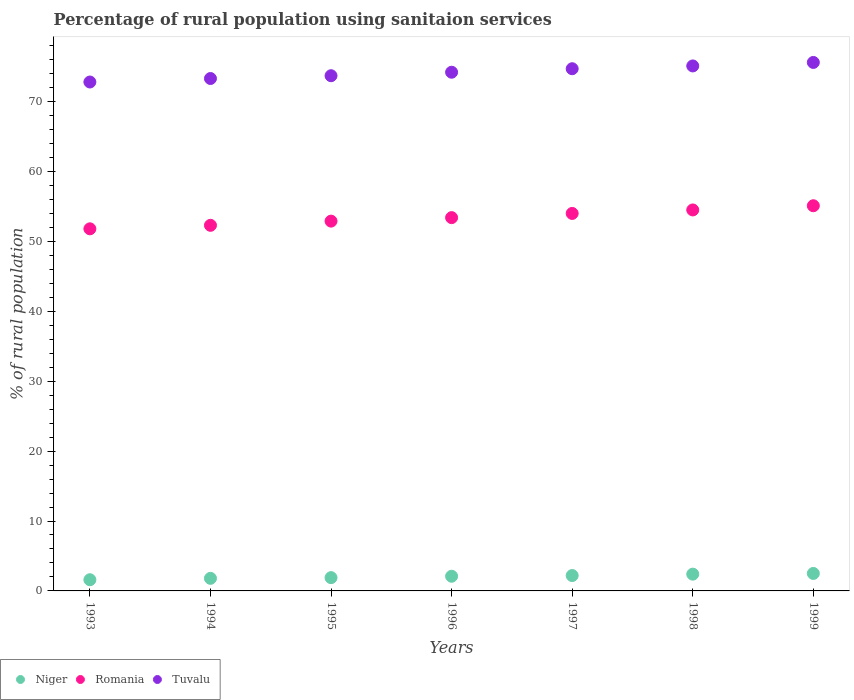What is the percentage of rural population using sanitaion services in Tuvalu in 1994?
Your response must be concise. 73.3. Across all years, what is the maximum percentage of rural population using sanitaion services in Tuvalu?
Make the answer very short. 75.6. Across all years, what is the minimum percentage of rural population using sanitaion services in Tuvalu?
Your answer should be compact. 72.8. In which year was the percentage of rural population using sanitaion services in Tuvalu maximum?
Your answer should be very brief. 1999. In which year was the percentage of rural population using sanitaion services in Niger minimum?
Ensure brevity in your answer.  1993. What is the total percentage of rural population using sanitaion services in Romania in the graph?
Make the answer very short. 374. What is the difference between the percentage of rural population using sanitaion services in Niger in 1993 and that in 1998?
Your answer should be compact. -0.8. What is the difference between the percentage of rural population using sanitaion services in Tuvalu in 1998 and the percentage of rural population using sanitaion services in Romania in 1997?
Your answer should be compact. 21.1. What is the average percentage of rural population using sanitaion services in Tuvalu per year?
Give a very brief answer. 74.2. In the year 1996, what is the difference between the percentage of rural population using sanitaion services in Romania and percentage of rural population using sanitaion services in Niger?
Your answer should be very brief. 51.3. What is the ratio of the percentage of rural population using sanitaion services in Niger in 1995 to that in 1997?
Provide a succinct answer. 0.86. Is the percentage of rural population using sanitaion services in Romania in 1993 less than that in 1998?
Provide a short and direct response. Yes. What is the difference between the highest and the lowest percentage of rural population using sanitaion services in Romania?
Provide a short and direct response. 3.3. In how many years, is the percentage of rural population using sanitaion services in Niger greater than the average percentage of rural population using sanitaion services in Niger taken over all years?
Provide a succinct answer. 4. Is the sum of the percentage of rural population using sanitaion services in Niger in 1995 and 1999 greater than the maximum percentage of rural population using sanitaion services in Romania across all years?
Your response must be concise. No. Is it the case that in every year, the sum of the percentage of rural population using sanitaion services in Romania and percentage of rural population using sanitaion services in Tuvalu  is greater than the percentage of rural population using sanitaion services in Niger?
Offer a terse response. Yes. Is the percentage of rural population using sanitaion services in Niger strictly less than the percentage of rural population using sanitaion services in Romania over the years?
Keep it short and to the point. Yes. How many dotlines are there?
Keep it short and to the point. 3. Are the values on the major ticks of Y-axis written in scientific E-notation?
Offer a terse response. No. Does the graph contain any zero values?
Make the answer very short. No. Does the graph contain grids?
Provide a short and direct response. No. How are the legend labels stacked?
Provide a short and direct response. Horizontal. What is the title of the graph?
Your response must be concise. Percentage of rural population using sanitaion services. What is the label or title of the X-axis?
Keep it short and to the point. Years. What is the label or title of the Y-axis?
Your response must be concise. % of rural population. What is the % of rural population in Niger in 1993?
Ensure brevity in your answer.  1.6. What is the % of rural population in Romania in 1993?
Give a very brief answer. 51.8. What is the % of rural population of Tuvalu in 1993?
Offer a terse response. 72.8. What is the % of rural population in Niger in 1994?
Provide a short and direct response. 1.8. What is the % of rural population in Romania in 1994?
Make the answer very short. 52.3. What is the % of rural population in Tuvalu in 1994?
Ensure brevity in your answer.  73.3. What is the % of rural population of Niger in 1995?
Your answer should be very brief. 1.9. What is the % of rural population in Romania in 1995?
Give a very brief answer. 52.9. What is the % of rural population in Tuvalu in 1995?
Ensure brevity in your answer.  73.7. What is the % of rural population of Romania in 1996?
Offer a terse response. 53.4. What is the % of rural population in Tuvalu in 1996?
Offer a terse response. 74.2. What is the % of rural population in Niger in 1997?
Provide a succinct answer. 2.2. What is the % of rural population in Romania in 1997?
Your answer should be compact. 54. What is the % of rural population of Tuvalu in 1997?
Ensure brevity in your answer.  74.7. What is the % of rural population of Romania in 1998?
Your answer should be compact. 54.5. What is the % of rural population of Tuvalu in 1998?
Your response must be concise. 75.1. What is the % of rural population of Niger in 1999?
Make the answer very short. 2.5. What is the % of rural population in Romania in 1999?
Provide a succinct answer. 55.1. What is the % of rural population of Tuvalu in 1999?
Make the answer very short. 75.6. Across all years, what is the maximum % of rural population of Niger?
Give a very brief answer. 2.5. Across all years, what is the maximum % of rural population in Romania?
Your response must be concise. 55.1. Across all years, what is the maximum % of rural population in Tuvalu?
Keep it short and to the point. 75.6. Across all years, what is the minimum % of rural population of Romania?
Your answer should be very brief. 51.8. Across all years, what is the minimum % of rural population of Tuvalu?
Give a very brief answer. 72.8. What is the total % of rural population of Niger in the graph?
Offer a very short reply. 14.5. What is the total % of rural population in Romania in the graph?
Provide a succinct answer. 374. What is the total % of rural population of Tuvalu in the graph?
Your response must be concise. 519.4. What is the difference between the % of rural population in Niger in 1993 and that in 1994?
Offer a very short reply. -0.2. What is the difference between the % of rural population in Romania in 1993 and that in 1995?
Keep it short and to the point. -1.1. What is the difference between the % of rural population of Tuvalu in 1993 and that in 1996?
Make the answer very short. -1.4. What is the difference between the % of rural population of Niger in 1993 and that in 1997?
Your response must be concise. -0.6. What is the difference between the % of rural population in Niger in 1993 and that in 1998?
Ensure brevity in your answer.  -0.8. What is the difference between the % of rural population of Romania in 1993 and that in 1998?
Your response must be concise. -2.7. What is the difference between the % of rural population in Tuvalu in 1993 and that in 1998?
Keep it short and to the point. -2.3. What is the difference between the % of rural population in Romania in 1993 and that in 1999?
Ensure brevity in your answer.  -3.3. What is the difference between the % of rural population of Tuvalu in 1993 and that in 1999?
Your answer should be very brief. -2.8. What is the difference between the % of rural population in Niger in 1994 and that in 1995?
Make the answer very short. -0.1. What is the difference between the % of rural population of Tuvalu in 1994 and that in 1995?
Offer a very short reply. -0.4. What is the difference between the % of rural population in Niger in 1994 and that in 1996?
Provide a succinct answer. -0.3. What is the difference between the % of rural population of Romania in 1994 and that in 1996?
Your response must be concise. -1.1. What is the difference between the % of rural population of Tuvalu in 1994 and that in 1996?
Offer a terse response. -0.9. What is the difference between the % of rural population of Niger in 1994 and that in 1997?
Your response must be concise. -0.4. What is the difference between the % of rural population of Romania in 1994 and that in 1997?
Give a very brief answer. -1.7. What is the difference between the % of rural population of Niger in 1994 and that in 1998?
Keep it short and to the point. -0.6. What is the difference between the % of rural population in Tuvalu in 1994 and that in 1998?
Ensure brevity in your answer.  -1.8. What is the difference between the % of rural population in Niger in 1994 and that in 1999?
Keep it short and to the point. -0.7. What is the difference between the % of rural population of Tuvalu in 1994 and that in 1999?
Offer a very short reply. -2.3. What is the difference between the % of rural population of Niger in 1995 and that in 1996?
Provide a succinct answer. -0.2. What is the difference between the % of rural population in Romania in 1995 and that in 1996?
Ensure brevity in your answer.  -0.5. What is the difference between the % of rural population of Tuvalu in 1995 and that in 1996?
Offer a terse response. -0.5. What is the difference between the % of rural population in Niger in 1995 and that in 1997?
Make the answer very short. -0.3. What is the difference between the % of rural population of Romania in 1995 and that in 1997?
Your response must be concise. -1.1. What is the difference between the % of rural population of Niger in 1995 and that in 1998?
Give a very brief answer. -0.5. What is the difference between the % of rural population of Romania in 1995 and that in 1998?
Your answer should be compact. -1.6. What is the difference between the % of rural population in Tuvalu in 1995 and that in 1998?
Provide a succinct answer. -1.4. What is the difference between the % of rural population in Niger in 1995 and that in 1999?
Make the answer very short. -0.6. What is the difference between the % of rural population in Niger in 1996 and that in 1999?
Keep it short and to the point. -0.4. What is the difference between the % of rural population in Niger in 1997 and that in 1998?
Make the answer very short. -0.2. What is the difference between the % of rural population of Romania in 1997 and that in 1998?
Offer a terse response. -0.5. What is the difference between the % of rural population of Tuvalu in 1997 and that in 1998?
Keep it short and to the point. -0.4. What is the difference between the % of rural population of Niger in 1993 and the % of rural population of Romania in 1994?
Offer a terse response. -50.7. What is the difference between the % of rural population in Niger in 1993 and the % of rural population in Tuvalu in 1994?
Offer a very short reply. -71.7. What is the difference between the % of rural population in Romania in 1993 and the % of rural population in Tuvalu in 1994?
Ensure brevity in your answer.  -21.5. What is the difference between the % of rural population of Niger in 1993 and the % of rural population of Romania in 1995?
Ensure brevity in your answer.  -51.3. What is the difference between the % of rural population of Niger in 1993 and the % of rural population of Tuvalu in 1995?
Your answer should be very brief. -72.1. What is the difference between the % of rural population of Romania in 1993 and the % of rural population of Tuvalu in 1995?
Your answer should be compact. -21.9. What is the difference between the % of rural population in Niger in 1993 and the % of rural population in Romania in 1996?
Ensure brevity in your answer.  -51.8. What is the difference between the % of rural population in Niger in 1993 and the % of rural population in Tuvalu in 1996?
Keep it short and to the point. -72.6. What is the difference between the % of rural population of Romania in 1993 and the % of rural population of Tuvalu in 1996?
Offer a very short reply. -22.4. What is the difference between the % of rural population of Niger in 1993 and the % of rural population of Romania in 1997?
Your answer should be compact. -52.4. What is the difference between the % of rural population in Niger in 1993 and the % of rural population in Tuvalu in 1997?
Your answer should be very brief. -73.1. What is the difference between the % of rural population of Romania in 1993 and the % of rural population of Tuvalu in 1997?
Provide a short and direct response. -22.9. What is the difference between the % of rural population of Niger in 1993 and the % of rural population of Romania in 1998?
Provide a short and direct response. -52.9. What is the difference between the % of rural population in Niger in 1993 and the % of rural population in Tuvalu in 1998?
Make the answer very short. -73.5. What is the difference between the % of rural population of Romania in 1993 and the % of rural population of Tuvalu in 1998?
Offer a terse response. -23.3. What is the difference between the % of rural population in Niger in 1993 and the % of rural population in Romania in 1999?
Offer a terse response. -53.5. What is the difference between the % of rural population in Niger in 1993 and the % of rural population in Tuvalu in 1999?
Keep it short and to the point. -74. What is the difference between the % of rural population of Romania in 1993 and the % of rural population of Tuvalu in 1999?
Your response must be concise. -23.8. What is the difference between the % of rural population in Niger in 1994 and the % of rural population in Romania in 1995?
Provide a short and direct response. -51.1. What is the difference between the % of rural population of Niger in 1994 and the % of rural population of Tuvalu in 1995?
Provide a short and direct response. -71.9. What is the difference between the % of rural population in Romania in 1994 and the % of rural population in Tuvalu in 1995?
Provide a short and direct response. -21.4. What is the difference between the % of rural population of Niger in 1994 and the % of rural population of Romania in 1996?
Your response must be concise. -51.6. What is the difference between the % of rural population in Niger in 1994 and the % of rural population in Tuvalu in 1996?
Your response must be concise. -72.4. What is the difference between the % of rural population in Romania in 1994 and the % of rural population in Tuvalu in 1996?
Provide a succinct answer. -21.9. What is the difference between the % of rural population of Niger in 1994 and the % of rural population of Romania in 1997?
Ensure brevity in your answer.  -52.2. What is the difference between the % of rural population in Niger in 1994 and the % of rural population in Tuvalu in 1997?
Your answer should be compact. -72.9. What is the difference between the % of rural population in Romania in 1994 and the % of rural population in Tuvalu in 1997?
Your response must be concise. -22.4. What is the difference between the % of rural population in Niger in 1994 and the % of rural population in Romania in 1998?
Give a very brief answer. -52.7. What is the difference between the % of rural population of Niger in 1994 and the % of rural population of Tuvalu in 1998?
Make the answer very short. -73.3. What is the difference between the % of rural population in Romania in 1994 and the % of rural population in Tuvalu in 1998?
Make the answer very short. -22.8. What is the difference between the % of rural population of Niger in 1994 and the % of rural population of Romania in 1999?
Keep it short and to the point. -53.3. What is the difference between the % of rural population in Niger in 1994 and the % of rural population in Tuvalu in 1999?
Provide a short and direct response. -73.8. What is the difference between the % of rural population of Romania in 1994 and the % of rural population of Tuvalu in 1999?
Provide a short and direct response. -23.3. What is the difference between the % of rural population of Niger in 1995 and the % of rural population of Romania in 1996?
Your response must be concise. -51.5. What is the difference between the % of rural population of Niger in 1995 and the % of rural population of Tuvalu in 1996?
Make the answer very short. -72.3. What is the difference between the % of rural population in Romania in 1995 and the % of rural population in Tuvalu in 1996?
Give a very brief answer. -21.3. What is the difference between the % of rural population in Niger in 1995 and the % of rural population in Romania in 1997?
Give a very brief answer. -52.1. What is the difference between the % of rural population in Niger in 1995 and the % of rural population in Tuvalu in 1997?
Offer a terse response. -72.8. What is the difference between the % of rural population in Romania in 1995 and the % of rural population in Tuvalu in 1997?
Ensure brevity in your answer.  -21.8. What is the difference between the % of rural population of Niger in 1995 and the % of rural population of Romania in 1998?
Keep it short and to the point. -52.6. What is the difference between the % of rural population of Niger in 1995 and the % of rural population of Tuvalu in 1998?
Your response must be concise. -73.2. What is the difference between the % of rural population in Romania in 1995 and the % of rural population in Tuvalu in 1998?
Keep it short and to the point. -22.2. What is the difference between the % of rural population of Niger in 1995 and the % of rural population of Romania in 1999?
Keep it short and to the point. -53.2. What is the difference between the % of rural population of Niger in 1995 and the % of rural population of Tuvalu in 1999?
Give a very brief answer. -73.7. What is the difference between the % of rural population in Romania in 1995 and the % of rural population in Tuvalu in 1999?
Keep it short and to the point. -22.7. What is the difference between the % of rural population in Niger in 1996 and the % of rural population in Romania in 1997?
Offer a very short reply. -51.9. What is the difference between the % of rural population in Niger in 1996 and the % of rural population in Tuvalu in 1997?
Provide a succinct answer. -72.6. What is the difference between the % of rural population of Romania in 1996 and the % of rural population of Tuvalu in 1997?
Keep it short and to the point. -21.3. What is the difference between the % of rural population in Niger in 1996 and the % of rural population in Romania in 1998?
Ensure brevity in your answer.  -52.4. What is the difference between the % of rural population in Niger in 1996 and the % of rural population in Tuvalu in 1998?
Ensure brevity in your answer.  -73. What is the difference between the % of rural population in Romania in 1996 and the % of rural population in Tuvalu in 1998?
Keep it short and to the point. -21.7. What is the difference between the % of rural population of Niger in 1996 and the % of rural population of Romania in 1999?
Provide a short and direct response. -53. What is the difference between the % of rural population of Niger in 1996 and the % of rural population of Tuvalu in 1999?
Keep it short and to the point. -73.5. What is the difference between the % of rural population in Romania in 1996 and the % of rural population in Tuvalu in 1999?
Your answer should be very brief. -22.2. What is the difference between the % of rural population of Niger in 1997 and the % of rural population of Romania in 1998?
Offer a very short reply. -52.3. What is the difference between the % of rural population of Niger in 1997 and the % of rural population of Tuvalu in 1998?
Offer a terse response. -72.9. What is the difference between the % of rural population of Romania in 1997 and the % of rural population of Tuvalu in 1998?
Your response must be concise. -21.1. What is the difference between the % of rural population in Niger in 1997 and the % of rural population in Romania in 1999?
Your answer should be very brief. -52.9. What is the difference between the % of rural population of Niger in 1997 and the % of rural population of Tuvalu in 1999?
Make the answer very short. -73.4. What is the difference between the % of rural population in Romania in 1997 and the % of rural population in Tuvalu in 1999?
Your answer should be compact. -21.6. What is the difference between the % of rural population in Niger in 1998 and the % of rural population in Romania in 1999?
Keep it short and to the point. -52.7. What is the difference between the % of rural population in Niger in 1998 and the % of rural population in Tuvalu in 1999?
Provide a short and direct response. -73.2. What is the difference between the % of rural population of Romania in 1998 and the % of rural population of Tuvalu in 1999?
Offer a very short reply. -21.1. What is the average % of rural population of Niger per year?
Offer a terse response. 2.07. What is the average % of rural population of Romania per year?
Your response must be concise. 53.43. What is the average % of rural population of Tuvalu per year?
Your response must be concise. 74.2. In the year 1993, what is the difference between the % of rural population in Niger and % of rural population in Romania?
Give a very brief answer. -50.2. In the year 1993, what is the difference between the % of rural population of Niger and % of rural population of Tuvalu?
Provide a short and direct response. -71.2. In the year 1993, what is the difference between the % of rural population in Romania and % of rural population in Tuvalu?
Offer a terse response. -21. In the year 1994, what is the difference between the % of rural population of Niger and % of rural population of Romania?
Provide a short and direct response. -50.5. In the year 1994, what is the difference between the % of rural population of Niger and % of rural population of Tuvalu?
Your answer should be very brief. -71.5. In the year 1995, what is the difference between the % of rural population in Niger and % of rural population in Romania?
Give a very brief answer. -51. In the year 1995, what is the difference between the % of rural population in Niger and % of rural population in Tuvalu?
Your answer should be very brief. -71.8. In the year 1995, what is the difference between the % of rural population in Romania and % of rural population in Tuvalu?
Your answer should be compact. -20.8. In the year 1996, what is the difference between the % of rural population of Niger and % of rural population of Romania?
Your answer should be very brief. -51.3. In the year 1996, what is the difference between the % of rural population in Niger and % of rural population in Tuvalu?
Offer a terse response. -72.1. In the year 1996, what is the difference between the % of rural population of Romania and % of rural population of Tuvalu?
Offer a terse response. -20.8. In the year 1997, what is the difference between the % of rural population in Niger and % of rural population in Romania?
Your response must be concise. -51.8. In the year 1997, what is the difference between the % of rural population of Niger and % of rural population of Tuvalu?
Give a very brief answer. -72.5. In the year 1997, what is the difference between the % of rural population of Romania and % of rural population of Tuvalu?
Offer a very short reply. -20.7. In the year 1998, what is the difference between the % of rural population of Niger and % of rural population of Romania?
Make the answer very short. -52.1. In the year 1998, what is the difference between the % of rural population of Niger and % of rural population of Tuvalu?
Offer a terse response. -72.7. In the year 1998, what is the difference between the % of rural population in Romania and % of rural population in Tuvalu?
Make the answer very short. -20.6. In the year 1999, what is the difference between the % of rural population of Niger and % of rural population of Romania?
Ensure brevity in your answer.  -52.6. In the year 1999, what is the difference between the % of rural population of Niger and % of rural population of Tuvalu?
Offer a very short reply. -73.1. In the year 1999, what is the difference between the % of rural population of Romania and % of rural population of Tuvalu?
Give a very brief answer. -20.5. What is the ratio of the % of rural population of Romania in 1993 to that in 1994?
Your response must be concise. 0.99. What is the ratio of the % of rural population of Niger in 1993 to that in 1995?
Ensure brevity in your answer.  0.84. What is the ratio of the % of rural population of Romania in 1993 to that in 1995?
Your response must be concise. 0.98. What is the ratio of the % of rural population of Tuvalu in 1993 to that in 1995?
Keep it short and to the point. 0.99. What is the ratio of the % of rural population of Niger in 1993 to that in 1996?
Offer a terse response. 0.76. What is the ratio of the % of rural population of Tuvalu in 1993 to that in 1996?
Ensure brevity in your answer.  0.98. What is the ratio of the % of rural population in Niger in 1993 to that in 1997?
Keep it short and to the point. 0.73. What is the ratio of the % of rural population in Romania in 1993 to that in 1997?
Ensure brevity in your answer.  0.96. What is the ratio of the % of rural population in Tuvalu in 1993 to that in 1997?
Your response must be concise. 0.97. What is the ratio of the % of rural population in Niger in 1993 to that in 1998?
Keep it short and to the point. 0.67. What is the ratio of the % of rural population in Romania in 1993 to that in 1998?
Offer a terse response. 0.95. What is the ratio of the % of rural population in Tuvalu in 1993 to that in 1998?
Provide a succinct answer. 0.97. What is the ratio of the % of rural population of Niger in 1993 to that in 1999?
Your answer should be very brief. 0.64. What is the ratio of the % of rural population in Romania in 1993 to that in 1999?
Keep it short and to the point. 0.94. What is the ratio of the % of rural population in Tuvalu in 1993 to that in 1999?
Make the answer very short. 0.96. What is the ratio of the % of rural population of Niger in 1994 to that in 1995?
Your response must be concise. 0.95. What is the ratio of the % of rural population in Romania in 1994 to that in 1995?
Keep it short and to the point. 0.99. What is the ratio of the % of rural population of Tuvalu in 1994 to that in 1995?
Provide a short and direct response. 0.99. What is the ratio of the % of rural population in Romania in 1994 to that in 1996?
Provide a short and direct response. 0.98. What is the ratio of the % of rural population of Tuvalu in 1994 to that in 1996?
Ensure brevity in your answer.  0.99. What is the ratio of the % of rural population of Niger in 1994 to that in 1997?
Offer a terse response. 0.82. What is the ratio of the % of rural population in Romania in 1994 to that in 1997?
Provide a succinct answer. 0.97. What is the ratio of the % of rural population of Tuvalu in 1994 to that in 1997?
Provide a short and direct response. 0.98. What is the ratio of the % of rural population in Romania in 1994 to that in 1998?
Your response must be concise. 0.96. What is the ratio of the % of rural population in Niger in 1994 to that in 1999?
Make the answer very short. 0.72. What is the ratio of the % of rural population of Romania in 1994 to that in 1999?
Offer a very short reply. 0.95. What is the ratio of the % of rural population in Tuvalu in 1994 to that in 1999?
Provide a short and direct response. 0.97. What is the ratio of the % of rural population of Niger in 1995 to that in 1996?
Ensure brevity in your answer.  0.9. What is the ratio of the % of rural population in Romania in 1995 to that in 1996?
Your response must be concise. 0.99. What is the ratio of the % of rural population in Niger in 1995 to that in 1997?
Make the answer very short. 0.86. What is the ratio of the % of rural population in Romania in 1995 to that in 1997?
Make the answer very short. 0.98. What is the ratio of the % of rural population of Tuvalu in 1995 to that in 1997?
Offer a very short reply. 0.99. What is the ratio of the % of rural population in Niger in 1995 to that in 1998?
Make the answer very short. 0.79. What is the ratio of the % of rural population in Romania in 1995 to that in 1998?
Make the answer very short. 0.97. What is the ratio of the % of rural population of Tuvalu in 1995 to that in 1998?
Give a very brief answer. 0.98. What is the ratio of the % of rural population of Niger in 1995 to that in 1999?
Ensure brevity in your answer.  0.76. What is the ratio of the % of rural population in Romania in 1995 to that in 1999?
Your response must be concise. 0.96. What is the ratio of the % of rural population of Tuvalu in 1995 to that in 1999?
Make the answer very short. 0.97. What is the ratio of the % of rural population in Niger in 1996 to that in 1997?
Provide a short and direct response. 0.95. What is the ratio of the % of rural population in Romania in 1996 to that in 1997?
Provide a short and direct response. 0.99. What is the ratio of the % of rural population of Tuvalu in 1996 to that in 1997?
Give a very brief answer. 0.99. What is the ratio of the % of rural population of Romania in 1996 to that in 1998?
Give a very brief answer. 0.98. What is the ratio of the % of rural population in Tuvalu in 1996 to that in 1998?
Your response must be concise. 0.99. What is the ratio of the % of rural population in Niger in 1996 to that in 1999?
Your response must be concise. 0.84. What is the ratio of the % of rural population of Romania in 1996 to that in 1999?
Your response must be concise. 0.97. What is the ratio of the % of rural population of Tuvalu in 1996 to that in 1999?
Your response must be concise. 0.98. What is the ratio of the % of rural population in Romania in 1997 to that in 1998?
Keep it short and to the point. 0.99. What is the ratio of the % of rural population of Tuvalu in 1997 to that in 1998?
Your answer should be very brief. 0.99. What is the ratio of the % of rural population of Romania in 1997 to that in 1999?
Keep it short and to the point. 0.98. What is the ratio of the % of rural population of Romania in 1998 to that in 1999?
Give a very brief answer. 0.99. What is the ratio of the % of rural population in Tuvalu in 1998 to that in 1999?
Your answer should be compact. 0.99. What is the difference between the highest and the second highest % of rural population of Romania?
Give a very brief answer. 0.6. What is the difference between the highest and the second highest % of rural population of Tuvalu?
Provide a short and direct response. 0.5. What is the difference between the highest and the lowest % of rural population of Romania?
Keep it short and to the point. 3.3. What is the difference between the highest and the lowest % of rural population of Tuvalu?
Your response must be concise. 2.8. 